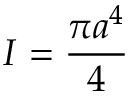Convert formula to latex. <formula><loc_0><loc_0><loc_500><loc_500>I = { \frac { \pi a ^ { 4 } } { 4 } }</formula> 